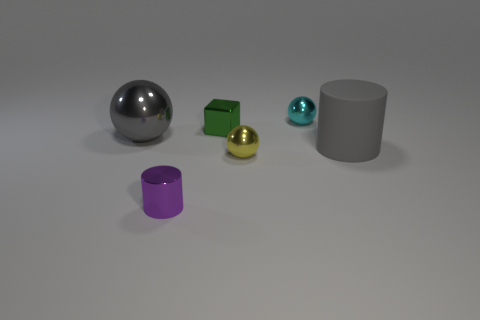What can you say about the textures present in the scene? The scene presents a variety of textures: the cube and cylinder have a matte finish, diffusing light softly; the sphere and the small teal object have reflective surfaces; and the hemisphere has a semi-matte texture with some shine. 